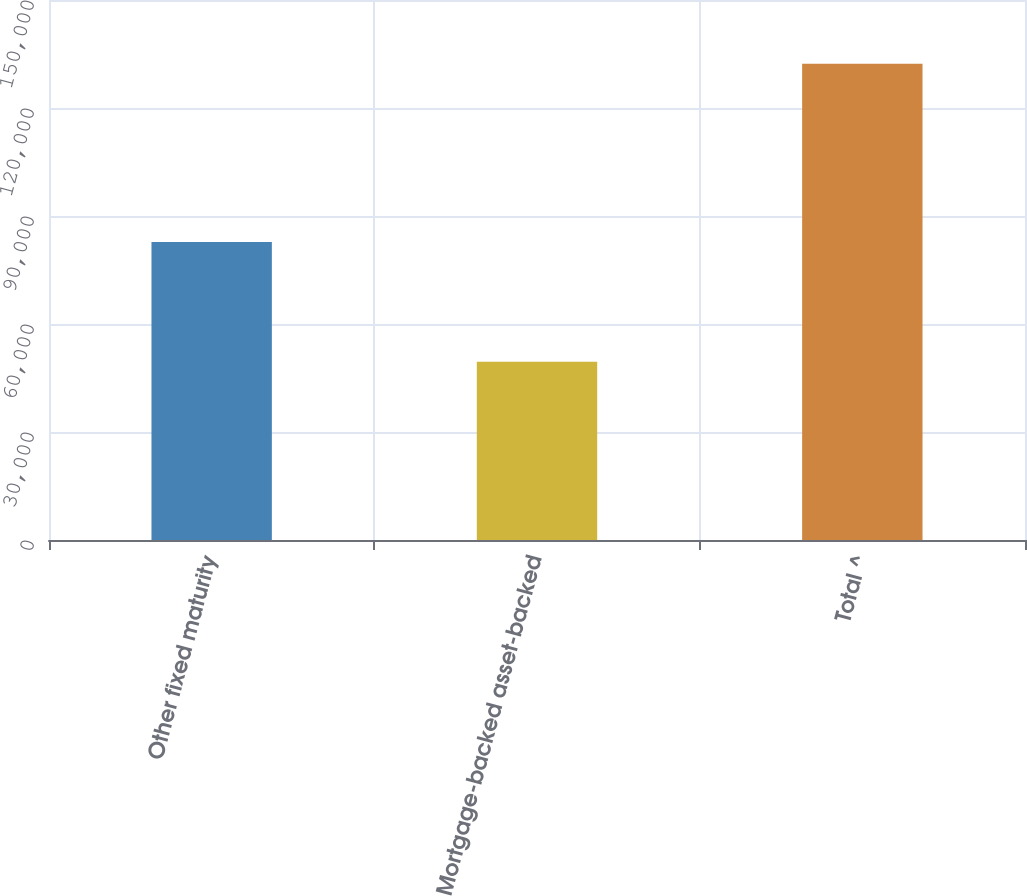Convert chart. <chart><loc_0><loc_0><loc_500><loc_500><bar_chart><fcel>Other fixed maturity<fcel>Mortgage-backed asset-backed<fcel>Total ^<nl><fcel>82798<fcel>49521<fcel>132319<nl></chart> 